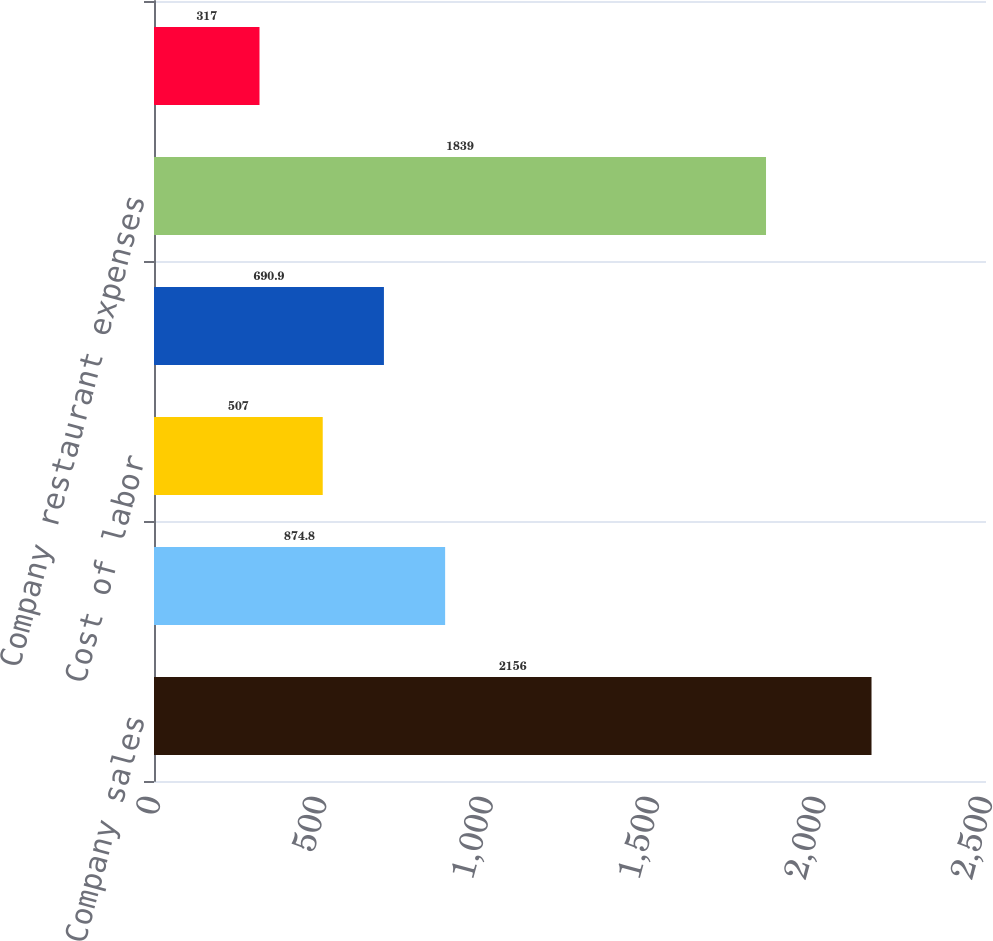<chart> <loc_0><loc_0><loc_500><loc_500><bar_chart><fcel>Company sales<fcel>Cost of sales<fcel>Cost of labor<fcel>Occupancy and other<fcel>Company restaurant expenses<fcel>Restaurant profit<nl><fcel>2156<fcel>874.8<fcel>507<fcel>690.9<fcel>1839<fcel>317<nl></chart> 